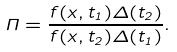<formula> <loc_0><loc_0><loc_500><loc_500>\Pi = \frac { f ( x , t _ { 1 } ) \Delta ( t _ { 2 } ) } { f ( x , t _ { 2 } ) \Delta ( t _ { 1 } ) } .</formula> 